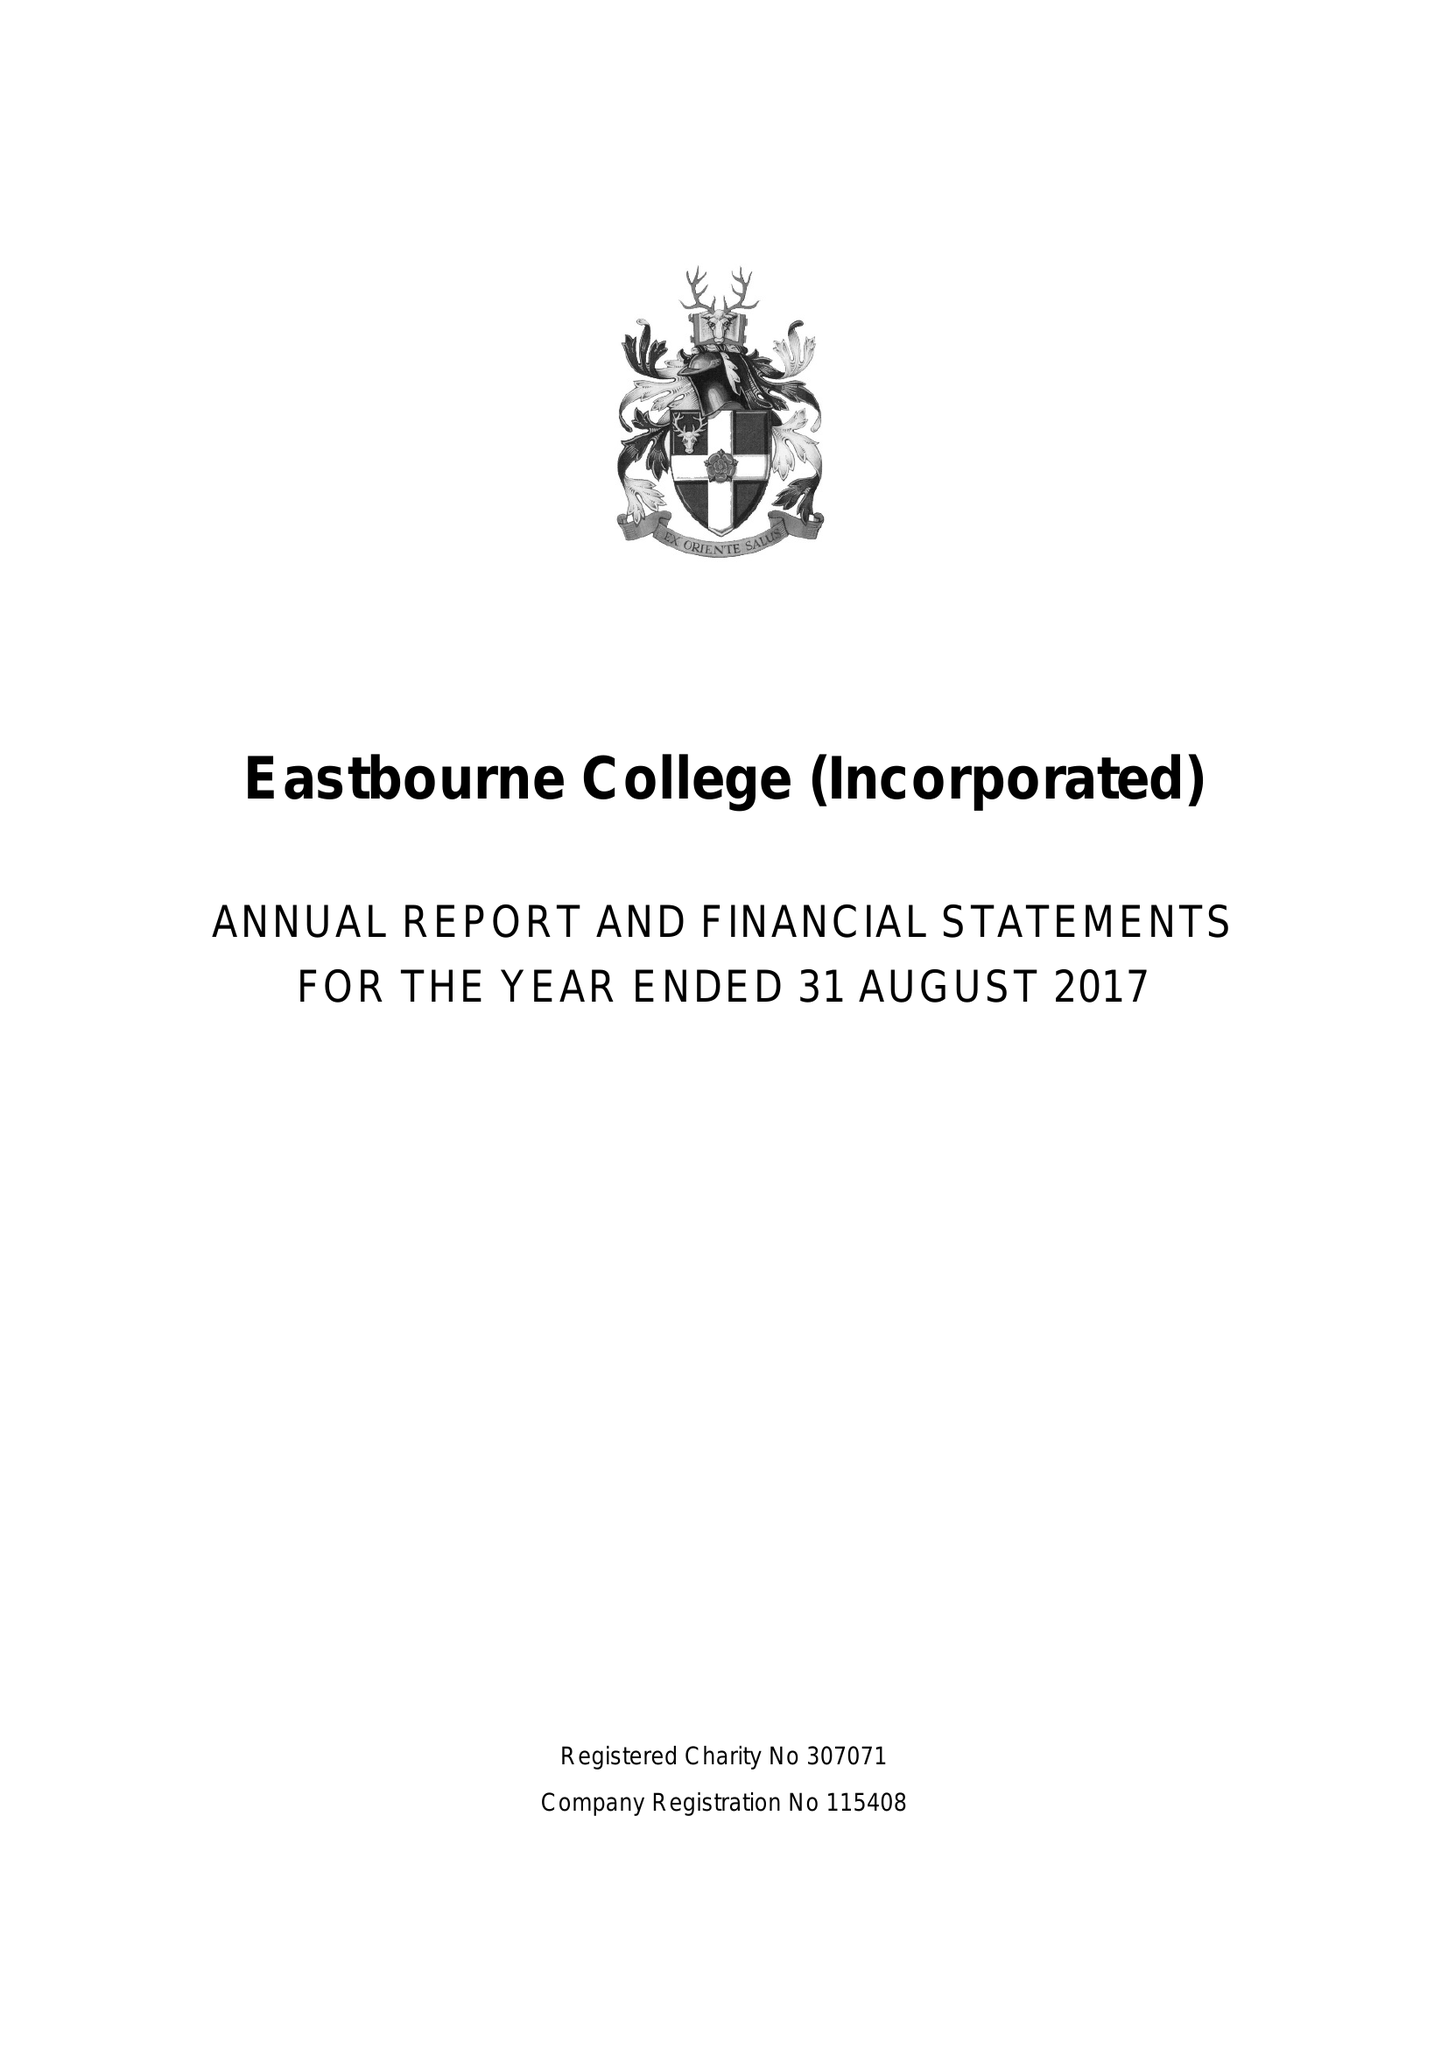What is the value for the charity_number?
Answer the question using a single word or phrase. 307071 